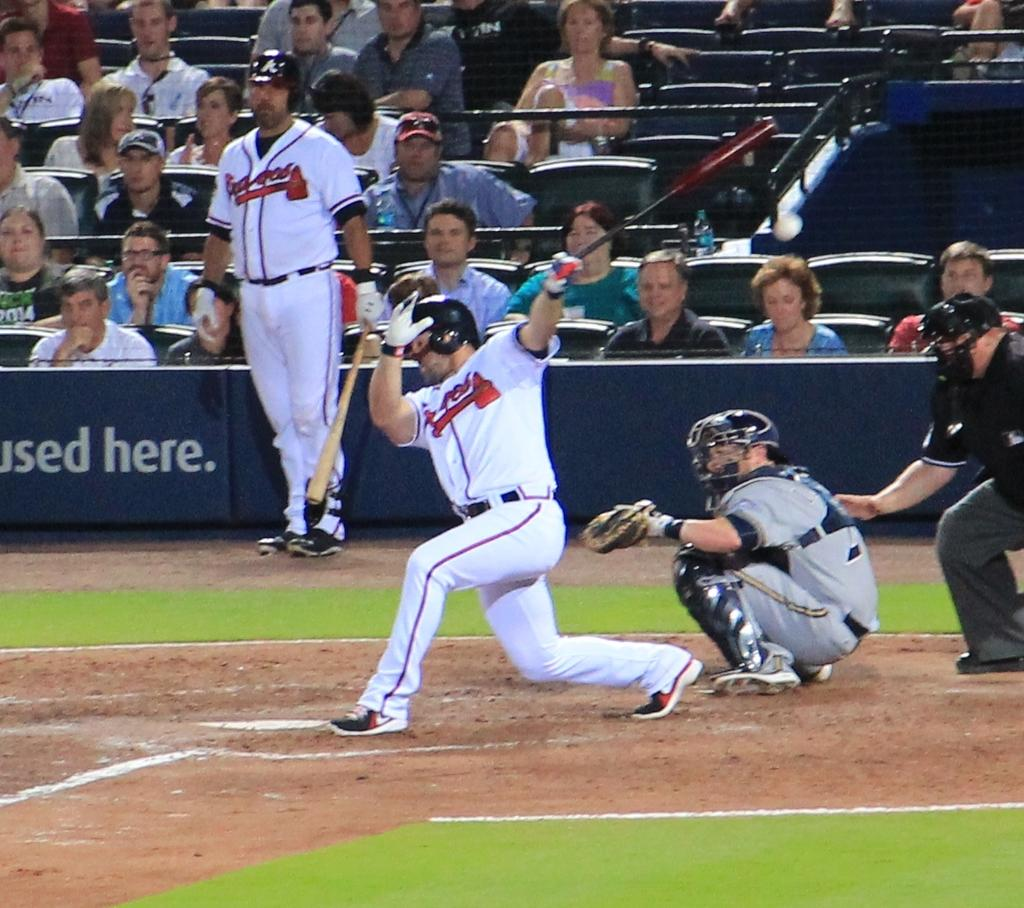<image>
Relay a brief, clear account of the picture shown. The batter is wearing a Braves baseball jersey 